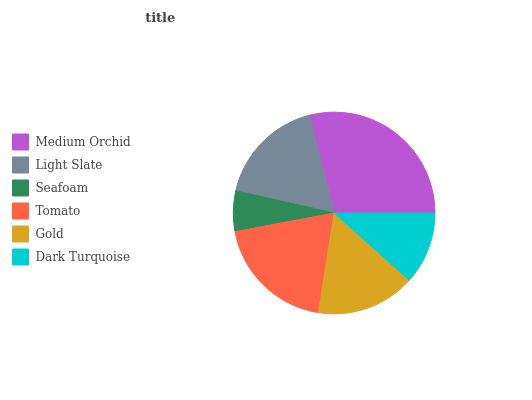Is Seafoam the minimum?
Answer yes or no. Yes. Is Medium Orchid the maximum?
Answer yes or no. Yes. Is Light Slate the minimum?
Answer yes or no. No. Is Light Slate the maximum?
Answer yes or no. No. Is Medium Orchid greater than Light Slate?
Answer yes or no. Yes. Is Light Slate less than Medium Orchid?
Answer yes or no. Yes. Is Light Slate greater than Medium Orchid?
Answer yes or no. No. Is Medium Orchid less than Light Slate?
Answer yes or no. No. Is Light Slate the high median?
Answer yes or no. Yes. Is Gold the low median?
Answer yes or no. Yes. Is Seafoam the high median?
Answer yes or no. No. Is Dark Turquoise the low median?
Answer yes or no. No. 